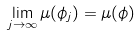Convert formula to latex. <formula><loc_0><loc_0><loc_500><loc_500>\lim _ { j \to \infty } \mu ( \phi _ { j } ) = \mu ( \phi )</formula> 